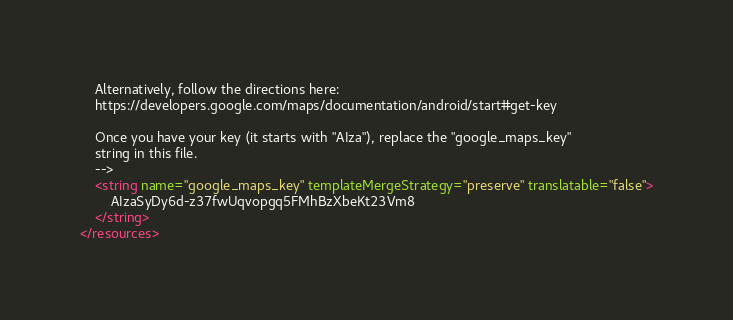Convert code to text. <code><loc_0><loc_0><loc_500><loc_500><_XML_>    Alternatively, follow the directions here:
    https://developers.google.com/maps/documentation/android/start#get-key

    Once you have your key (it starts with "AIza"), replace the "google_maps_key"
    string in this file.
    -->
    <string name="google_maps_key" templateMergeStrategy="preserve" translatable="false">
        AIzaSyDy6d-z37fwUqvopgq5FMhBzXbeKt23Vm8
    </string>
</resources>
</code> 